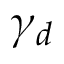Convert formula to latex. <formula><loc_0><loc_0><loc_500><loc_500>\gamma _ { d }</formula> 